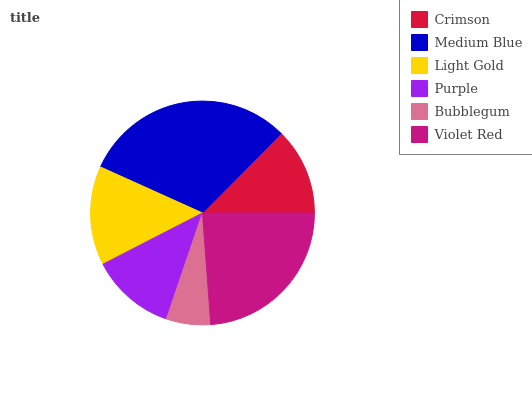Is Bubblegum the minimum?
Answer yes or no. Yes. Is Medium Blue the maximum?
Answer yes or no. Yes. Is Light Gold the minimum?
Answer yes or no. No. Is Light Gold the maximum?
Answer yes or no. No. Is Medium Blue greater than Light Gold?
Answer yes or no. Yes. Is Light Gold less than Medium Blue?
Answer yes or no. Yes. Is Light Gold greater than Medium Blue?
Answer yes or no. No. Is Medium Blue less than Light Gold?
Answer yes or no. No. Is Light Gold the high median?
Answer yes or no. Yes. Is Crimson the low median?
Answer yes or no. Yes. Is Medium Blue the high median?
Answer yes or no. No. Is Light Gold the low median?
Answer yes or no. No. 